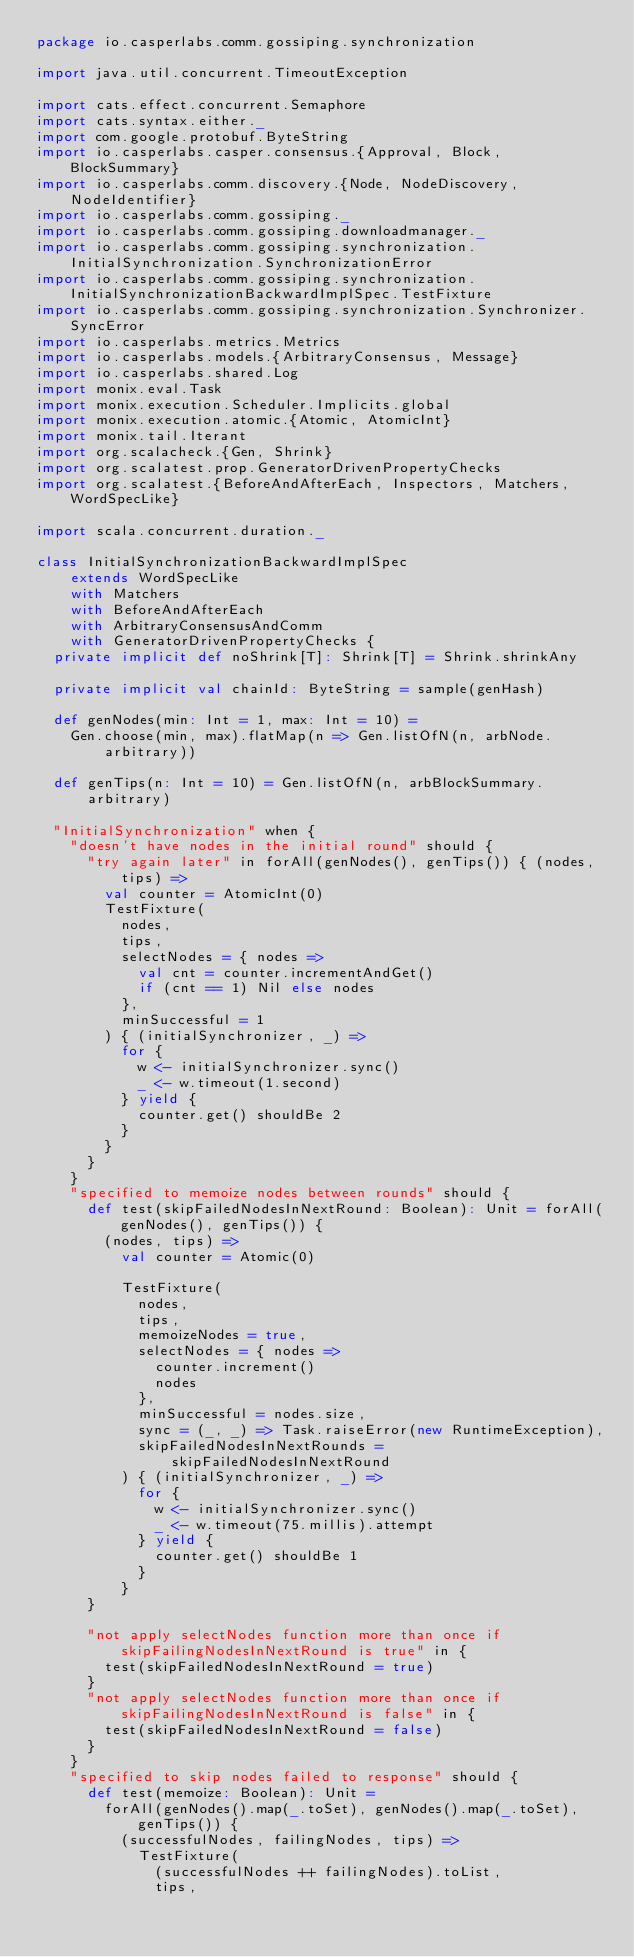Convert code to text. <code><loc_0><loc_0><loc_500><loc_500><_Scala_>package io.casperlabs.comm.gossiping.synchronization

import java.util.concurrent.TimeoutException

import cats.effect.concurrent.Semaphore
import cats.syntax.either._
import com.google.protobuf.ByteString
import io.casperlabs.casper.consensus.{Approval, Block, BlockSummary}
import io.casperlabs.comm.discovery.{Node, NodeDiscovery, NodeIdentifier}
import io.casperlabs.comm.gossiping._
import io.casperlabs.comm.gossiping.downloadmanager._
import io.casperlabs.comm.gossiping.synchronization.InitialSynchronization.SynchronizationError
import io.casperlabs.comm.gossiping.synchronization.InitialSynchronizationBackwardImplSpec.TestFixture
import io.casperlabs.comm.gossiping.synchronization.Synchronizer.SyncError
import io.casperlabs.metrics.Metrics
import io.casperlabs.models.{ArbitraryConsensus, Message}
import io.casperlabs.shared.Log
import monix.eval.Task
import monix.execution.Scheduler.Implicits.global
import monix.execution.atomic.{Atomic, AtomicInt}
import monix.tail.Iterant
import org.scalacheck.{Gen, Shrink}
import org.scalatest.prop.GeneratorDrivenPropertyChecks
import org.scalatest.{BeforeAndAfterEach, Inspectors, Matchers, WordSpecLike}

import scala.concurrent.duration._

class InitialSynchronizationBackwardImplSpec
    extends WordSpecLike
    with Matchers
    with BeforeAndAfterEach
    with ArbitraryConsensusAndComm
    with GeneratorDrivenPropertyChecks {
  private implicit def noShrink[T]: Shrink[T] = Shrink.shrinkAny

  private implicit val chainId: ByteString = sample(genHash)

  def genNodes(min: Int = 1, max: Int = 10) =
    Gen.choose(min, max).flatMap(n => Gen.listOfN(n, arbNode.arbitrary))

  def genTips(n: Int = 10) = Gen.listOfN(n, arbBlockSummary.arbitrary)

  "InitialSynchronization" when {
    "doesn't have nodes in the initial round" should {
      "try again later" in forAll(genNodes(), genTips()) { (nodes, tips) =>
        val counter = AtomicInt(0)
        TestFixture(
          nodes,
          tips,
          selectNodes = { nodes =>
            val cnt = counter.incrementAndGet()
            if (cnt == 1) Nil else nodes
          },
          minSuccessful = 1
        ) { (initialSynchronizer, _) =>
          for {
            w <- initialSynchronizer.sync()
            _ <- w.timeout(1.second)
          } yield {
            counter.get() shouldBe 2
          }
        }
      }
    }
    "specified to memoize nodes between rounds" should {
      def test(skipFailedNodesInNextRound: Boolean): Unit = forAll(genNodes(), genTips()) {
        (nodes, tips) =>
          val counter = Atomic(0)

          TestFixture(
            nodes,
            tips,
            memoizeNodes = true,
            selectNodes = { nodes =>
              counter.increment()
              nodes
            },
            minSuccessful = nodes.size,
            sync = (_, _) => Task.raiseError(new RuntimeException),
            skipFailedNodesInNextRounds = skipFailedNodesInNextRound
          ) { (initialSynchronizer, _) =>
            for {
              w <- initialSynchronizer.sync()
              _ <- w.timeout(75.millis).attempt
            } yield {
              counter.get() shouldBe 1
            }
          }
      }

      "not apply selectNodes function more than once if skipFailingNodesInNextRound is true" in {
        test(skipFailedNodesInNextRound = true)
      }
      "not apply selectNodes function more than once if skipFailingNodesInNextRound is false" in {
        test(skipFailedNodesInNextRound = false)
      }
    }
    "specified to skip nodes failed to response" should {
      def test(memoize: Boolean): Unit =
        forAll(genNodes().map(_.toSet), genNodes().map(_.toSet), genTips()) {
          (successfulNodes, failingNodes, tips) =>
            TestFixture(
              (successfulNodes ++ failingNodes).toList,
              tips,</code> 